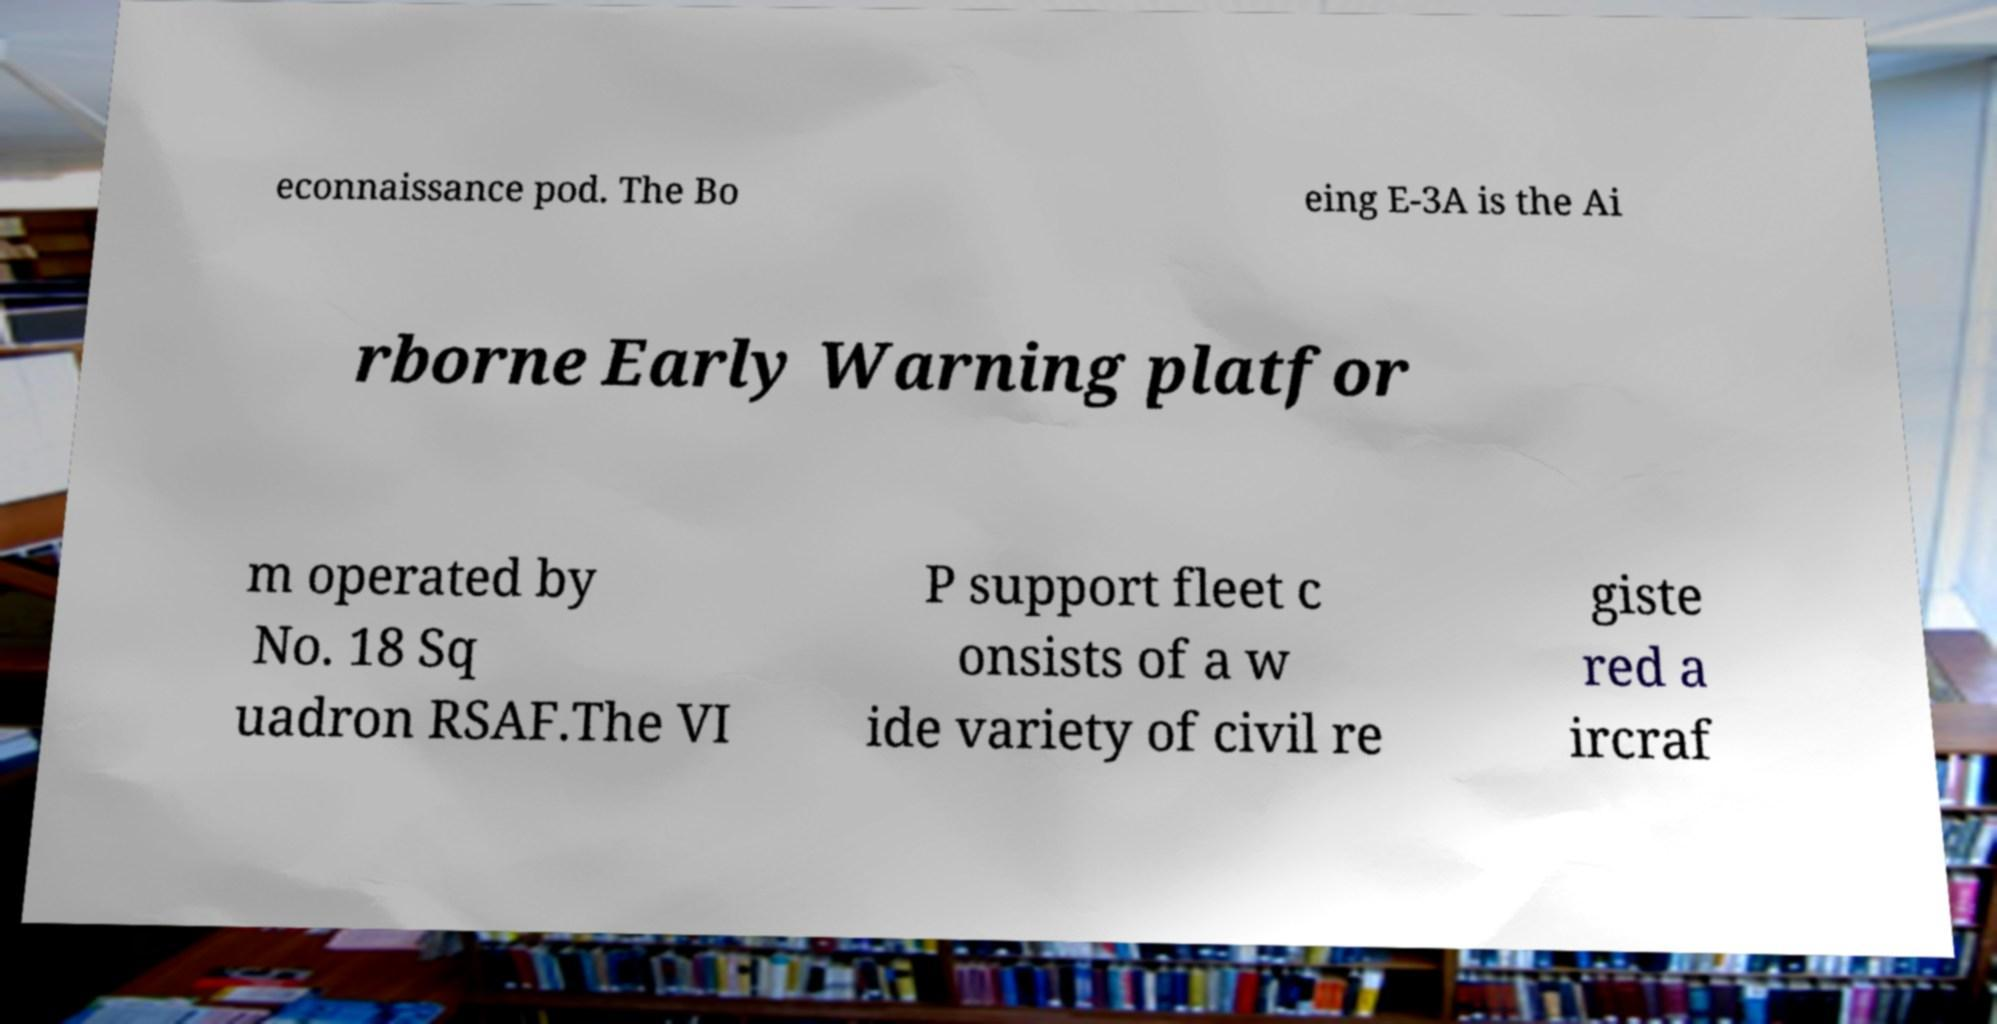For documentation purposes, I need the text within this image transcribed. Could you provide that? econnaissance pod. The Bo eing E-3A is the Ai rborne Early Warning platfor m operated by No. 18 Sq uadron RSAF.The VI P support fleet c onsists of a w ide variety of civil re giste red a ircraf 